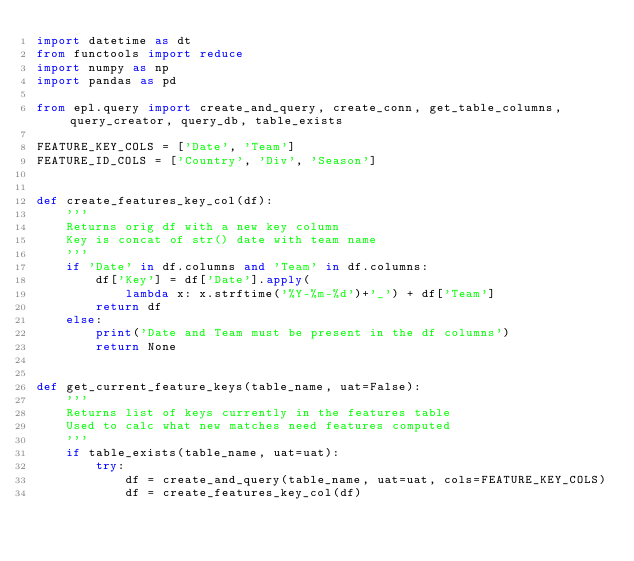<code> <loc_0><loc_0><loc_500><loc_500><_Python_>import datetime as dt
from functools import reduce
import numpy as np
import pandas as pd

from epl.query import create_and_query, create_conn, get_table_columns, query_creator, query_db, table_exists

FEATURE_KEY_COLS = ['Date', 'Team']
FEATURE_ID_COLS = ['Country', 'Div', 'Season']


def create_features_key_col(df):
    '''
    Returns orig df with a new key column
    Key is concat of str() date with team name
    '''
    if 'Date' in df.columns and 'Team' in df.columns:
        df['Key'] = df['Date'].apply(
            lambda x: x.strftime('%Y-%m-%d')+'_') + df['Team']
        return df
    else:
        print('Date and Team must be present in the df columns')
        return None


def get_current_feature_keys(table_name, uat=False):
    '''
    Returns list of keys currently in the features table
    Used to calc what new matches need features computed
    '''
    if table_exists(table_name, uat=uat):
        try:
            df = create_and_query(table_name, uat=uat, cols=FEATURE_KEY_COLS)
            df = create_features_key_col(df)</code> 